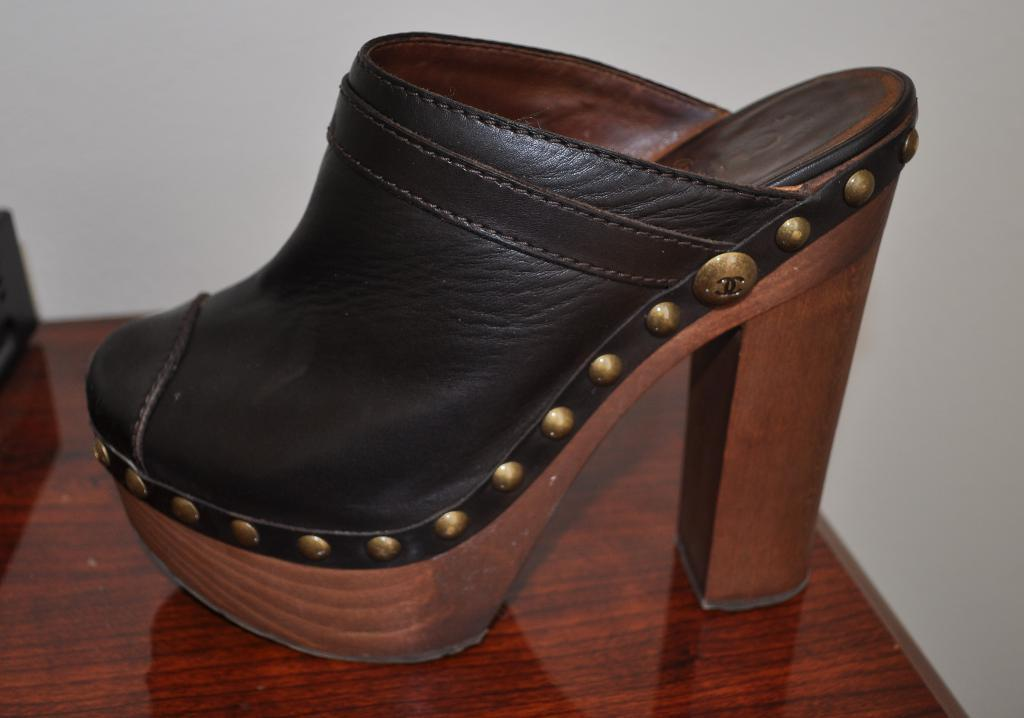What type of footwear is visible in the image? There is black and brown footwear in the image. What is the color of the surface on which the footwear is placed? The footwear is on a brown surface. What color is the background of the image? The background of the image is white. How many tails can be seen on the footwear in the image? There are no tails present on the footwear in the image. What type of map is visible on the brown surface? There is no map visible in the image; it features black and brown footwear on a brown surface with a white background. 